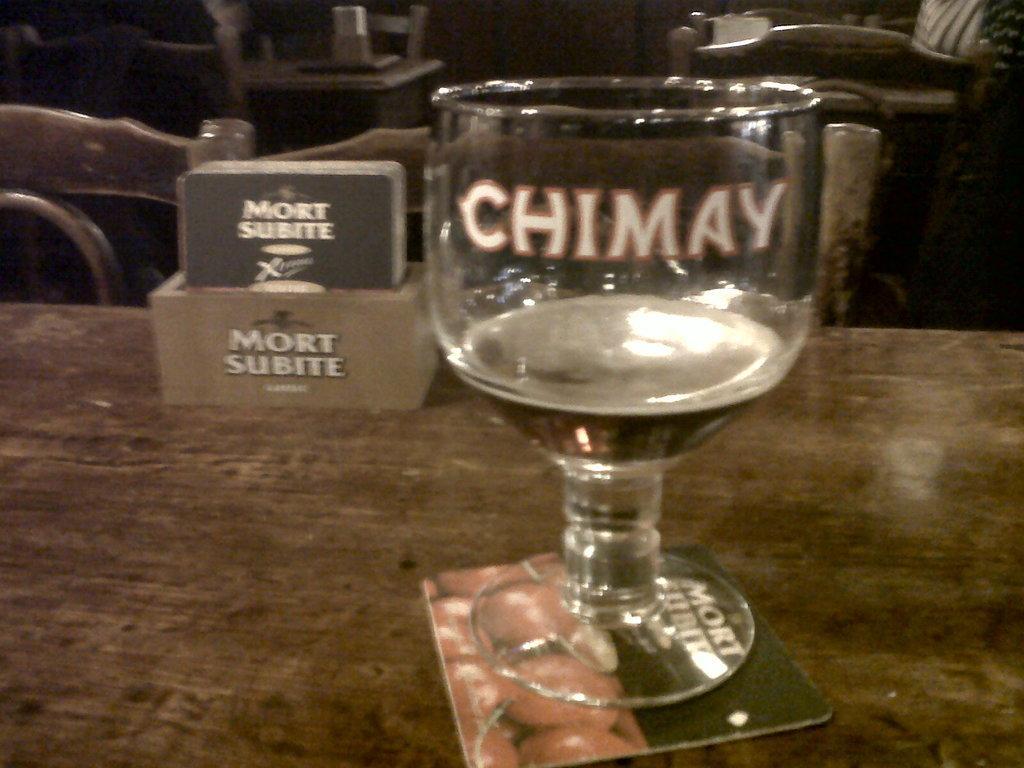Could you give a brief overview of what you see in this image? In this image we can see a glass with liquid in it on a small card on the table, small cards in a box and we can see chairs at the table. In the background we can see chairs and objects on the tables. 